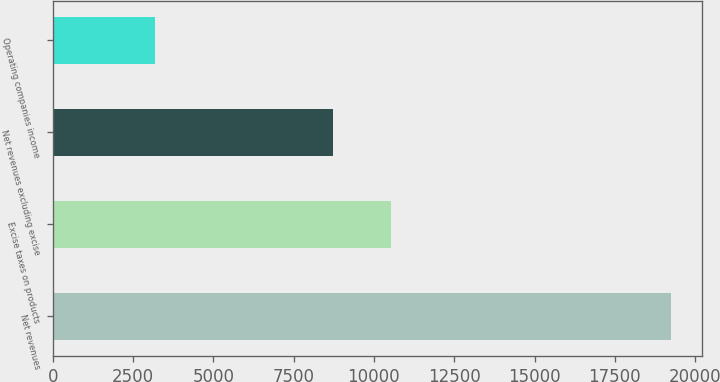Convert chart. <chart><loc_0><loc_0><loc_500><loc_500><bar_chart><fcel>Net revenues<fcel>Excise taxes on products<fcel>Net revenues excluding excise<fcel>Operating companies income<nl><fcel>19255<fcel>10527<fcel>8728<fcel>3187<nl></chart> 